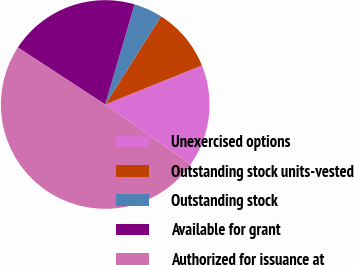Convert chart to OTSL. <chart><loc_0><loc_0><loc_500><loc_500><pie_chart><fcel>Unexercised options<fcel>Outstanding stock units-vested<fcel>Outstanding stock<fcel>Available for grant<fcel>Authorized for issuance at<nl><fcel>15.83%<fcel>9.9%<fcel>4.45%<fcel>20.34%<fcel>49.48%<nl></chart> 